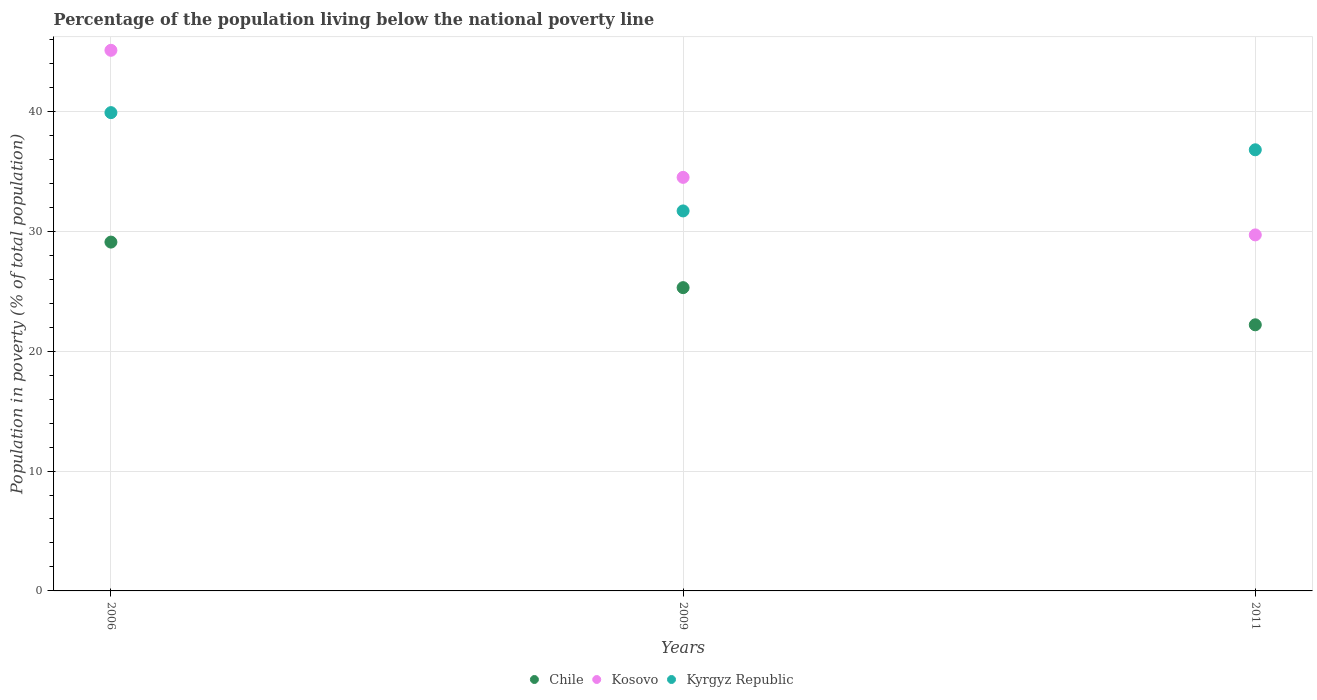How many different coloured dotlines are there?
Offer a terse response. 3. Is the number of dotlines equal to the number of legend labels?
Give a very brief answer. Yes. What is the percentage of the population living below the national poverty line in Kyrgyz Republic in 2006?
Your response must be concise. 39.9. Across all years, what is the maximum percentage of the population living below the national poverty line in Kyrgyz Republic?
Keep it short and to the point. 39.9. Across all years, what is the minimum percentage of the population living below the national poverty line in Kosovo?
Your answer should be compact. 29.7. In which year was the percentage of the population living below the national poverty line in Kosovo minimum?
Provide a succinct answer. 2011. What is the total percentage of the population living below the national poverty line in Kyrgyz Republic in the graph?
Offer a terse response. 108.4. What is the difference between the percentage of the population living below the national poverty line in Kyrgyz Republic in 2006 and that in 2011?
Your answer should be compact. 3.1. What is the difference between the percentage of the population living below the national poverty line in Kyrgyz Republic in 2006 and the percentage of the population living below the national poverty line in Kosovo in 2009?
Ensure brevity in your answer.  5.4. What is the average percentage of the population living below the national poverty line in Chile per year?
Give a very brief answer. 25.53. In the year 2011, what is the difference between the percentage of the population living below the national poverty line in Chile and percentage of the population living below the national poverty line in Kyrgyz Republic?
Keep it short and to the point. -14.6. What is the ratio of the percentage of the population living below the national poverty line in Kyrgyz Republic in 2006 to that in 2009?
Your answer should be very brief. 1.26. What is the difference between the highest and the second highest percentage of the population living below the national poverty line in Chile?
Make the answer very short. 3.8. What is the difference between the highest and the lowest percentage of the population living below the national poverty line in Chile?
Offer a very short reply. 6.9. Does the percentage of the population living below the national poverty line in Kyrgyz Republic monotonically increase over the years?
Give a very brief answer. No. How many dotlines are there?
Offer a very short reply. 3. How many years are there in the graph?
Ensure brevity in your answer.  3. Does the graph contain grids?
Give a very brief answer. Yes. Where does the legend appear in the graph?
Make the answer very short. Bottom center. What is the title of the graph?
Ensure brevity in your answer.  Percentage of the population living below the national poverty line. What is the label or title of the Y-axis?
Your answer should be compact. Population in poverty (% of total population). What is the Population in poverty (% of total population) of Chile in 2006?
Keep it short and to the point. 29.1. What is the Population in poverty (% of total population) of Kosovo in 2006?
Provide a succinct answer. 45.1. What is the Population in poverty (% of total population) of Kyrgyz Republic in 2006?
Provide a short and direct response. 39.9. What is the Population in poverty (% of total population) of Chile in 2009?
Ensure brevity in your answer.  25.3. What is the Population in poverty (% of total population) in Kosovo in 2009?
Your answer should be compact. 34.5. What is the Population in poverty (% of total population) in Kyrgyz Republic in 2009?
Keep it short and to the point. 31.7. What is the Population in poverty (% of total population) in Kosovo in 2011?
Your answer should be compact. 29.7. What is the Population in poverty (% of total population) in Kyrgyz Republic in 2011?
Give a very brief answer. 36.8. Across all years, what is the maximum Population in poverty (% of total population) of Chile?
Your response must be concise. 29.1. Across all years, what is the maximum Population in poverty (% of total population) in Kosovo?
Keep it short and to the point. 45.1. Across all years, what is the maximum Population in poverty (% of total population) of Kyrgyz Republic?
Your answer should be compact. 39.9. Across all years, what is the minimum Population in poverty (% of total population) in Kosovo?
Offer a very short reply. 29.7. Across all years, what is the minimum Population in poverty (% of total population) of Kyrgyz Republic?
Make the answer very short. 31.7. What is the total Population in poverty (% of total population) of Chile in the graph?
Offer a very short reply. 76.6. What is the total Population in poverty (% of total population) in Kosovo in the graph?
Your answer should be compact. 109.3. What is the total Population in poverty (% of total population) of Kyrgyz Republic in the graph?
Your answer should be very brief. 108.4. What is the difference between the Population in poverty (% of total population) of Chile in 2006 and that in 2009?
Your answer should be compact. 3.8. What is the difference between the Population in poverty (% of total population) in Kosovo in 2006 and that in 2009?
Your response must be concise. 10.6. What is the difference between the Population in poverty (% of total population) of Kosovo in 2006 and that in 2011?
Ensure brevity in your answer.  15.4. What is the difference between the Population in poverty (% of total population) in Kyrgyz Republic in 2006 and that in 2011?
Provide a succinct answer. 3.1. What is the difference between the Population in poverty (% of total population) in Chile in 2009 and that in 2011?
Ensure brevity in your answer.  3.1. What is the difference between the Population in poverty (% of total population) in Kyrgyz Republic in 2009 and that in 2011?
Your response must be concise. -5.1. What is the difference between the Population in poverty (% of total population) of Chile in 2006 and the Population in poverty (% of total population) of Kyrgyz Republic in 2009?
Provide a succinct answer. -2.6. What is the difference between the Population in poverty (% of total population) of Chile in 2009 and the Population in poverty (% of total population) of Kosovo in 2011?
Keep it short and to the point. -4.4. What is the average Population in poverty (% of total population) of Chile per year?
Offer a very short reply. 25.53. What is the average Population in poverty (% of total population) in Kosovo per year?
Give a very brief answer. 36.43. What is the average Population in poverty (% of total population) of Kyrgyz Republic per year?
Provide a succinct answer. 36.13. In the year 2006, what is the difference between the Population in poverty (% of total population) of Chile and Population in poverty (% of total population) of Kyrgyz Republic?
Give a very brief answer. -10.8. In the year 2009, what is the difference between the Population in poverty (% of total population) in Chile and Population in poverty (% of total population) in Kosovo?
Your response must be concise. -9.2. In the year 2009, what is the difference between the Population in poverty (% of total population) of Chile and Population in poverty (% of total population) of Kyrgyz Republic?
Ensure brevity in your answer.  -6.4. In the year 2009, what is the difference between the Population in poverty (% of total population) of Kosovo and Population in poverty (% of total population) of Kyrgyz Republic?
Provide a short and direct response. 2.8. In the year 2011, what is the difference between the Population in poverty (% of total population) in Chile and Population in poverty (% of total population) in Kyrgyz Republic?
Make the answer very short. -14.6. In the year 2011, what is the difference between the Population in poverty (% of total population) in Kosovo and Population in poverty (% of total population) in Kyrgyz Republic?
Provide a short and direct response. -7.1. What is the ratio of the Population in poverty (% of total population) of Chile in 2006 to that in 2009?
Your answer should be compact. 1.15. What is the ratio of the Population in poverty (% of total population) in Kosovo in 2006 to that in 2009?
Offer a terse response. 1.31. What is the ratio of the Population in poverty (% of total population) of Kyrgyz Republic in 2006 to that in 2009?
Provide a succinct answer. 1.26. What is the ratio of the Population in poverty (% of total population) in Chile in 2006 to that in 2011?
Keep it short and to the point. 1.31. What is the ratio of the Population in poverty (% of total population) in Kosovo in 2006 to that in 2011?
Offer a very short reply. 1.52. What is the ratio of the Population in poverty (% of total population) of Kyrgyz Republic in 2006 to that in 2011?
Give a very brief answer. 1.08. What is the ratio of the Population in poverty (% of total population) in Chile in 2009 to that in 2011?
Keep it short and to the point. 1.14. What is the ratio of the Population in poverty (% of total population) of Kosovo in 2009 to that in 2011?
Offer a very short reply. 1.16. What is the ratio of the Population in poverty (% of total population) of Kyrgyz Republic in 2009 to that in 2011?
Give a very brief answer. 0.86. What is the difference between the highest and the second highest Population in poverty (% of total population) in Chile?
Ensure brevity in your answer.  3.8. What is the difference between the highest and the lowest Population in poverty (% of total population) in Chile?
Offer a very short reply. 6.9. 